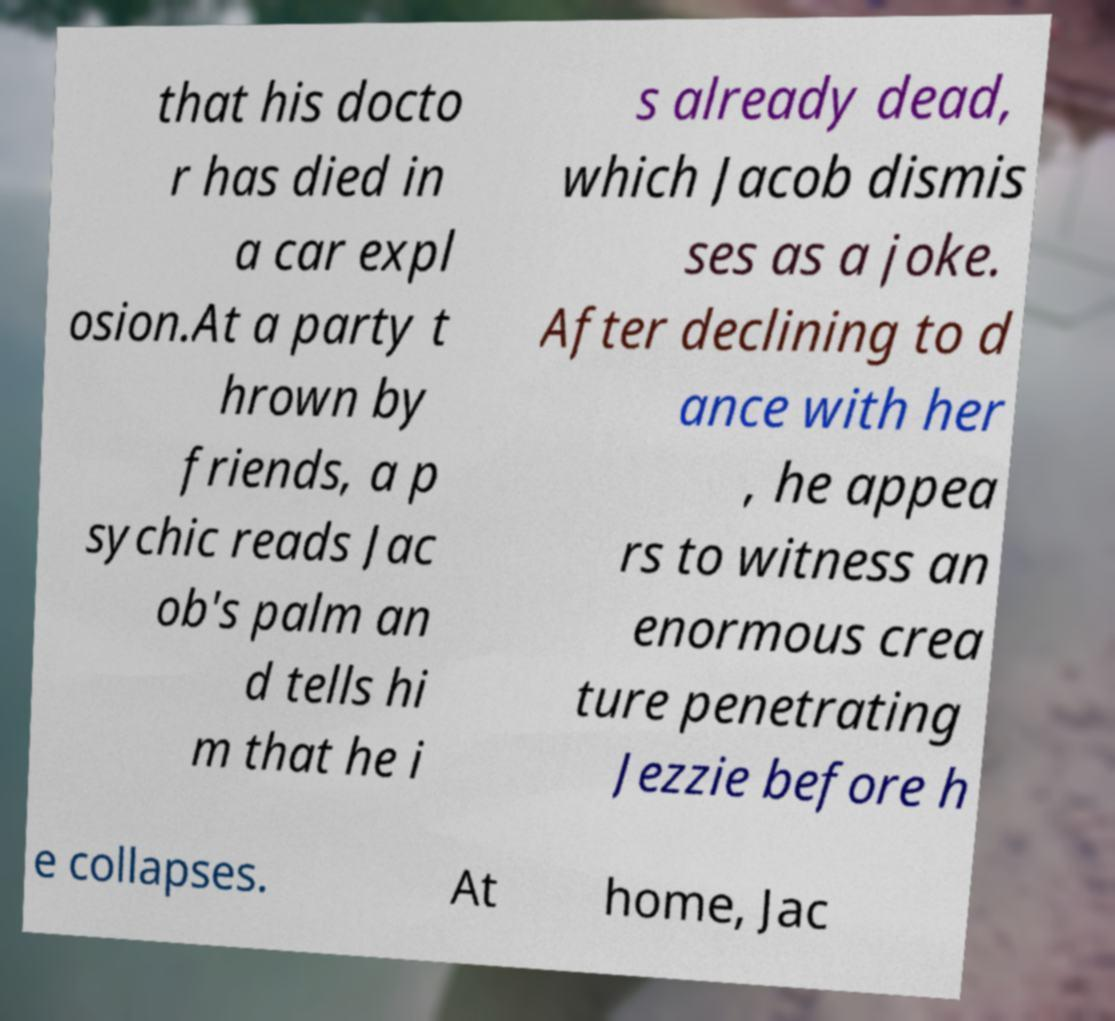Please read and relay the text visible in this image. What does it say? that his docto r has died in a car expl osion.At a party t hrown by friends, a p sychic reads Jac ob's palm an d tells hi m that he i s already dead, which Jacob dismis ses as a joke. After declining to d ance with her , he appea rs to witness an enormous crea ture penetrating Jezzie before h e collapses. At home, Jac 